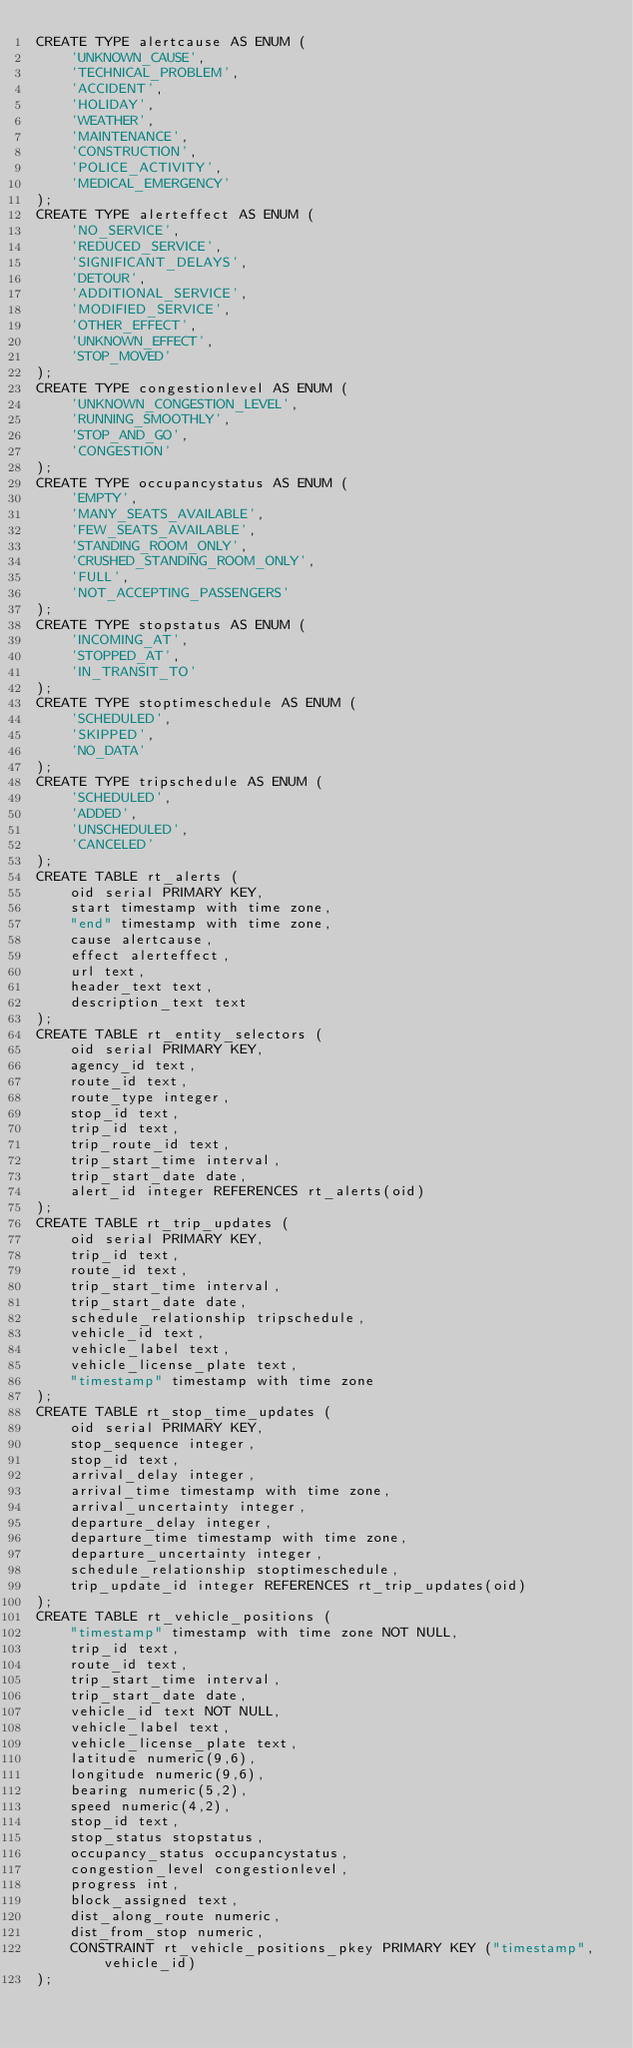Convert code to text. <code><loc_0><loc_0><loc_500><loc_500><_SQL_>CREATE TYPE alertcause AS ENUM (
    'UNKNOWN_CAUSE',
    'TECHNICAL_PROBLEM',
    'ACCIDENT',
    'HOLIDAY',
    'WEATHER',
    'MAINTENANCE',
    'CONSTRUCTION',
    'POLICE_ACTIVITY',
    'MEDICAL_EMERGENCY'
);
CREATE TYPE alerteffect AS ENUM (
    'NO_SERVICE',
    'REDUCED_SERVICE',
    'SIGNIFICANT_DELAYS',
    'DETOUR',
    'ADDITIONAL_SERVICE',
    'MODIFIED_SERVICE',
    'OTHER_EFFECT',
    'UNKNOWN_EFFECT',
    'STOP_MOVED'
);
CREATE TYPE congestionlevel AS ENUM (
    'UNKNOWN_CONGESTION_LEVEL',
    'RUNNING_SMOOTHLY',
    'STOP_AND_GO',
    'CONGESTION'
);
CREATE TYPE occupancystatus AS ENUM (
    'EMPTY',
    'MANY_SEATS_AVAILABLE',
    'FEW_SEATS_AVAILABLE',
    'STANDING_ROOM_ONLY',
    'CRUSHED_STANDING_ROOM_ONLY',
    'FULL',
    'NOT_ACCEPTING_PASSENGERS'
);
CREATE TYPE stopstatus AS ENUM (
    'INCOMING_AT',
    'STOPPED_AT',
    'IN_TRANSIT_TO'
);
CREATE TYPE stoptimeschedule AS ENUM (
    'SCHEDULED',
    'SKIPPED',
    'NO_DATA'
);
CREATE TYPE tripschedule AS ENUM (
    'SCHEDULED',
    'ADDED',
    'UNSCHEDULED',
    'CANCELED'
);
CREATE TABLE rt_alerts (
    oid serial PRIMARY KEY,
    start timestamp with time zone,
    "end" timestamp with time zone,
    cause alertcause,
    effect alerteffect,
    url text,
    header_text text,
    description_text text
);
CREATE TABLE rt_entity_selectors (
    oid serial PRIMARY KEY,
    agency_id text,
    route_id text,
    route_type integer,
    stop_id text,
    trip_id text,
    trip_route_id text,
    trip_start_time interval,
    trip_start_date date,
    alert_id integer REFERENCES rt_alerts(oid)
);
CREATE TABLE rt_trip_updates (
    oid serial PRIMARY KEY,
    trip_id text,
    route_id text,
    trip_start_time interval,
    trip_start_date date,
    schedule_relationship tripschedule,
    vehicle_id text,
    vehicle_label text,
    vehicle_license_plate text,
    "timestamp" timestamp with time zone
);
CREATE TABLE rt_stop_time_updates (
    oid serial PRIMARY KEY,
    stop_sequence integer,
    stop_id text,
    arrival_delay integer,
    arrival_time timestamp with time zone,
    arrival_uncertainty integer,
    departure_delay integer,
    departure_time timestamp with time zone,
    departure_uncertainty integer,
    schedule_relationship stoptimeschedule,
    trip_update_id integer REFERENCES rt_trip_updates(oid)
);
CREATE TABLE rt_vehicle_positions (
    "timestamp" timestamp with time zone NOT NULL,
    trip_id text,
    route_id text,
    trip_start_time interval,
    trip_start_date date,
    vehicle_id text NOT NULL,
    vehicle_label text,
    vehicle_license_plate text,
    latitude numeric(9,6),
    longitude numeric(9,6),
    bearing numeric(5,2),
    speed numeric(4,2),
    stop_id text,
    stop_status stopstatus,
    occupancy_status occupancystatus,
    congestion_level congestionlevel,
    progress int,
    block_assigned text,
    dist_along_route numeric,
    dist_from_stop numeric,
    CONSTRAINT rt_vehicle_positions_pkey PRIMARY KEY ("timestamp", vehicle_id)
);
</code> 